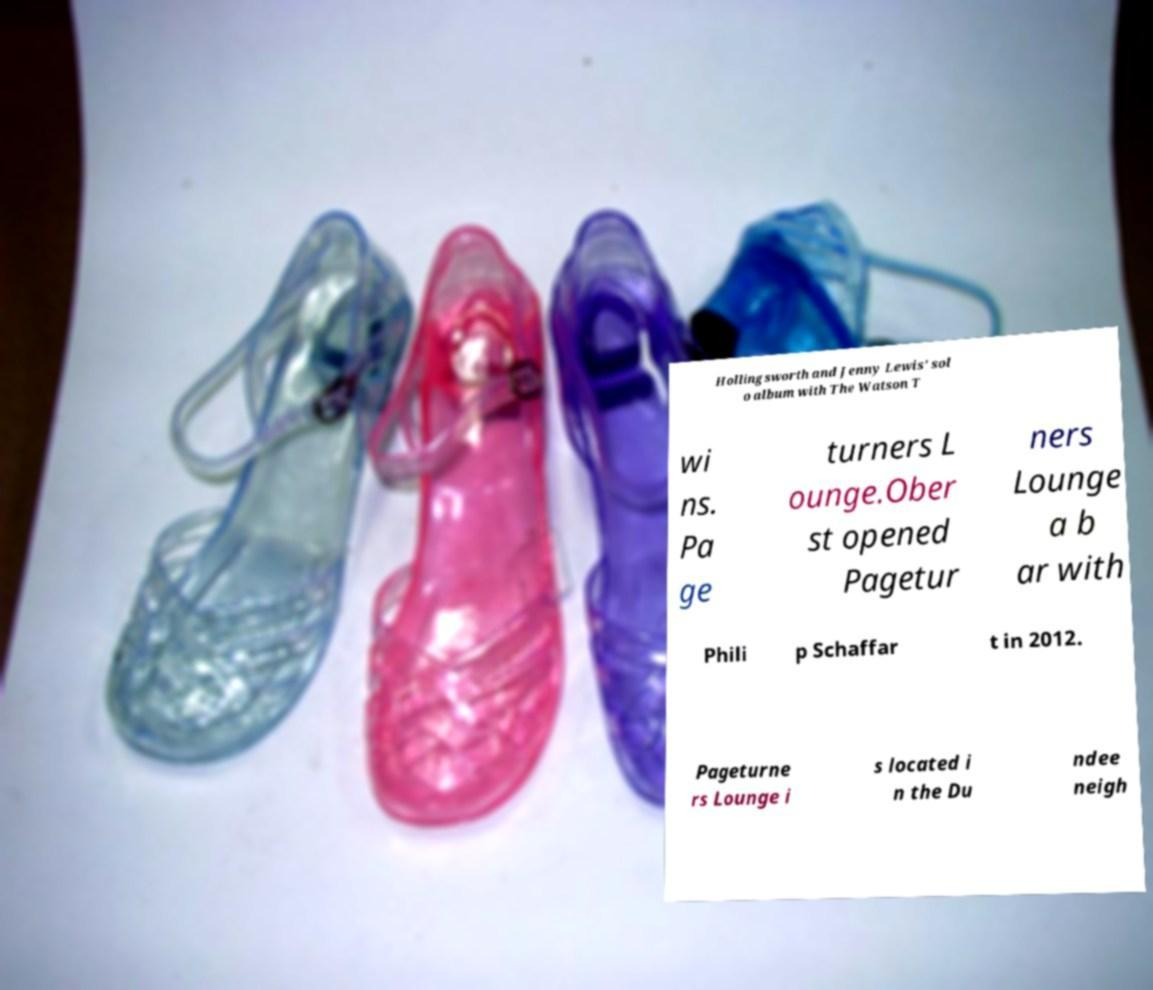Could you assist in decoding the text presented in this image and type it out clearly? Hollingsworth and Jenny Lewis' sol o album with The Watson T wi ns. Pa ge turners L ounge.Ober st opened Pagetur ners Lounge a b ar with Phili p Schaffar t in 2012. Pageturne rs Lounge i s located i n the Du ndee neigh 